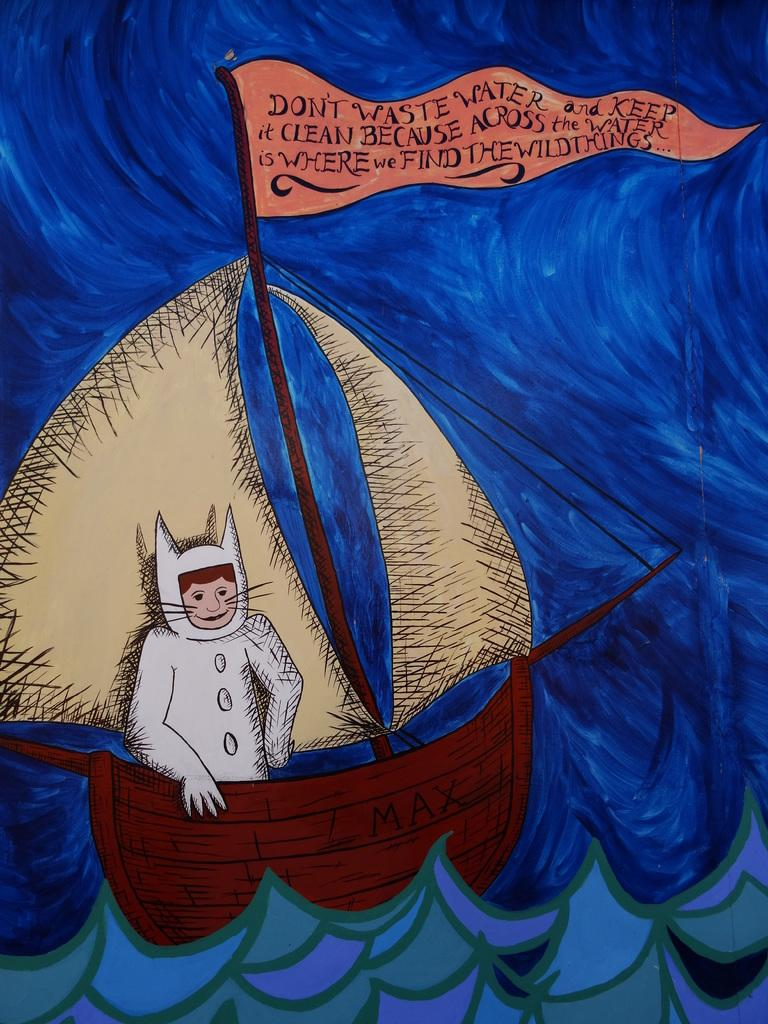What is the main subject of the painting in the image? The painting depicts a man sitting on a boat. Are there any other elements in the painting besides the man and the boat? Yes, there is a flag beside the man in the painting. What might the bottom of the painting represent? The bottom of the painting might represent water. Can you tell me how many moms are present in the painting? There are no moms depicted in the painting; it features a man sitting on a boat and a flag. What type of frog can be seen swimming in the water below the boat? There is no frog present in the image; the bottom of the painting might represent water, but no specific creatures are depicted. 